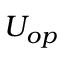Convert formula to latex. <formula><loc_0><loc_0><loc_500><loc_500>U _ { o p }</formula> 